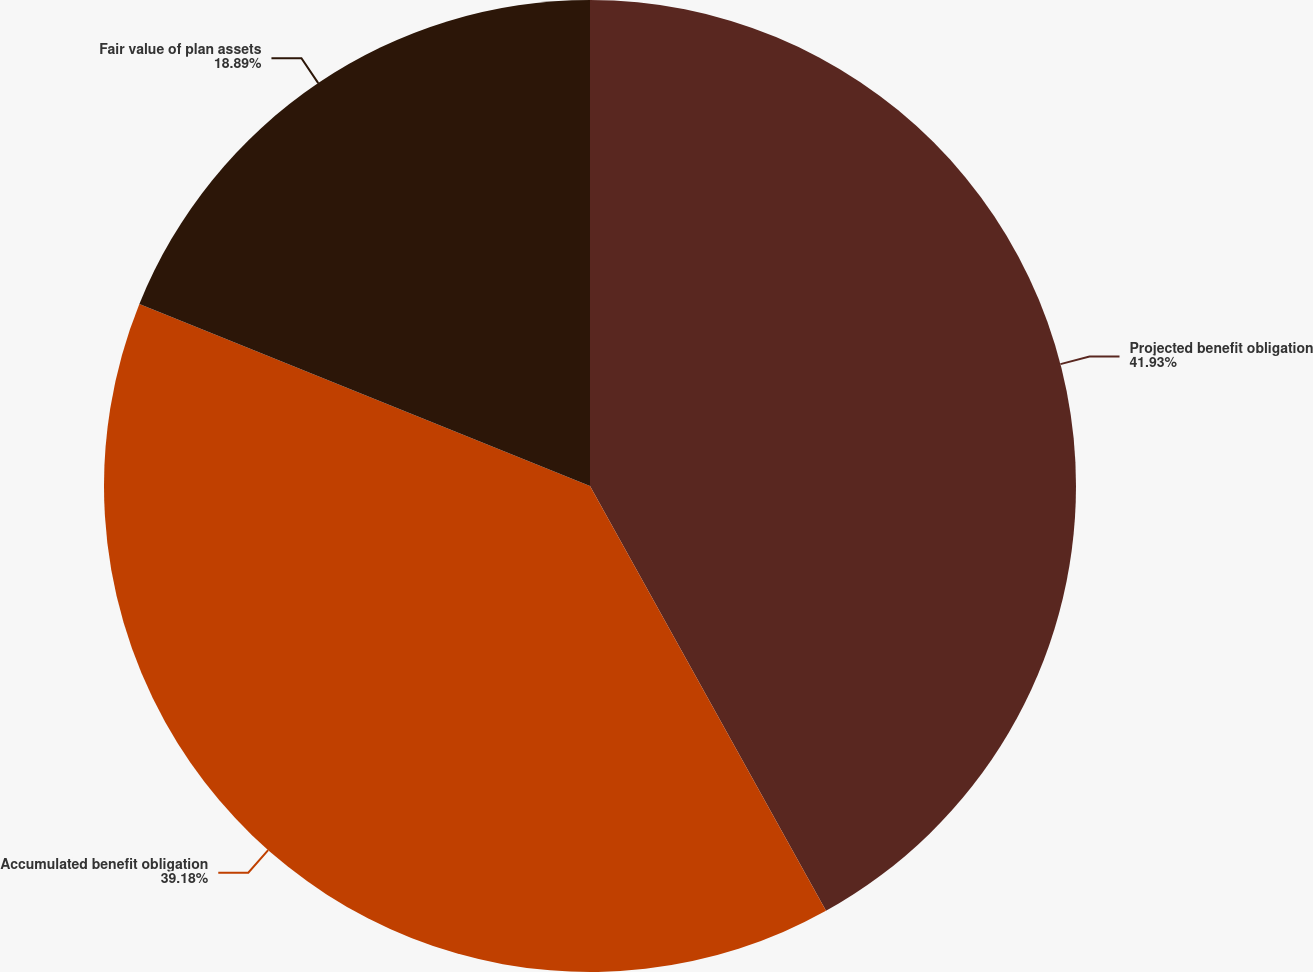<chart> <loc_0><loc_0><loc_500><loc_500><pie_chart><fcel>Projected benefit obligation<fcel>Accumulated benefit obligation<fcel>Fair value of plan assets<nl><fcel>41.93%<fcel>39.18%<fcel>18.89%<nl></chart> 